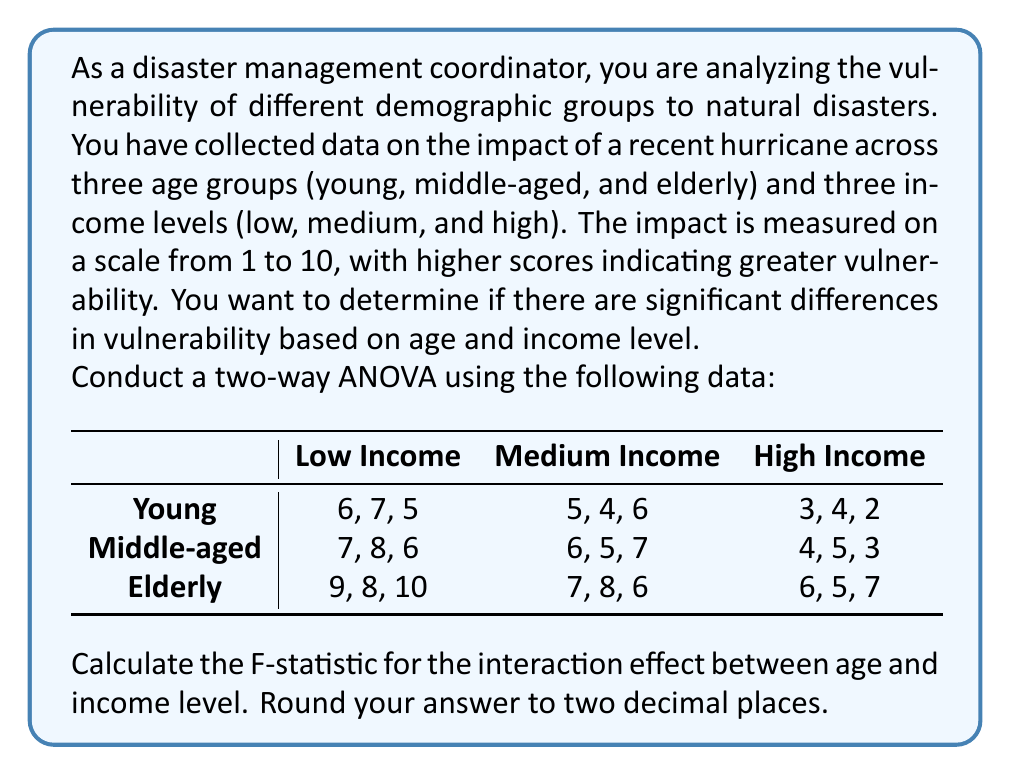What is the answer to this math problem? To conduct a two-way ANOVA and calculate the F-statistic for the interaction effect, we'll follow these steps:

1. Calculate the sum of squares for the interaction (SS_interaction)
2. Calculate the degrees of freedom for the interaction (df_interaction)
3. Calculate the mean square for the interaction (MS_interaction)
4. Calculate the sum of squares for error (SS_error)
5. Calculate the degrees of freedom for error (df_error)
6. Calculate the mean square for error (MS_error)
7. Calculate the F-statistic

Step 1: Calculate SS_interaction

First, we need to calculate the grand mean, row means, column means, and cell means.

Grand mean: $\bar{X} = 5.89$

Row means:
Young: 4.67
Middle-aged: 5.67
Elderly: 7.33

Column means:
Low Income: 7.33
Medium Income: 6.00
High Income: 4.33

Cell means:
$$
\begin{array}{c|ccc}
 & \text{Low Income} & \text{Medium Income} & \text{High Income} \\
\hline
\text{Young} & 6.00 & 5.00 & 3.00 \\
\text{Middle-aged} & 7.00 & 6.00 & 4.00 \\
\text{Elderly} & 9.00 & 7.00 & 6.00 \\
\end{array}
$$

Now, we can calculate SS_interaction:

$$SS_{interaction} = \sum_{i=1}^{a}\sum_{j=1}^{b}n_{ij}(\bar{X}_{ij} - \bar{X}_{i.} - \bar{X}_{.j} + \bar{X})^2$$

SS_interaction = 3.00

Step 2: Calculate df_interaction

df_interaction = (a - 1)(b - 1) = (3 - 1)(3 - 1) = 4

Step 3: Calculate MS_interaction

MS_interaction = SS_interaction / df_interaction = 3.00 / 4 = 0.75

Step 4: Calculate SS_error

$$SS_{error} = \sum_{i=1}^{a}\sum_{j=1}^{b}\sum_{k=1}^{n_{ij}}(X_{ijk} - \bar{X}_{ij})^2$$

SS_error = 12.00

Step 5: Calculate df_error

df_error = N - ab = 27 - 9 = 18

Step 6: Calculate MS_error

MS_error = SS_error / df_error = 12.00 / 18 = 0.67

Step 7: Calculate F-statistic

F = MS_interaction / MS_error = 0.75 / 0.67 = 1.12

Rounding to two decimal places, we get 1.12.
Answer: 1.12 